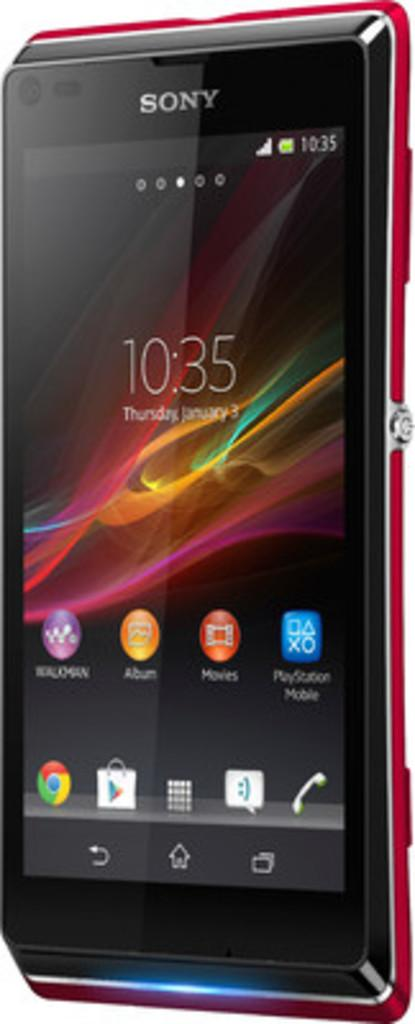<image>
Present a compact description of the photo's key features. a Sony cell phone with a screen showing the time as 10:35 